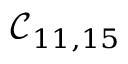<formula> <loc_0><loc_0><loc_500><loc_500>\mathcal { C } _ { 1 1 , 1 5 }</formula> 